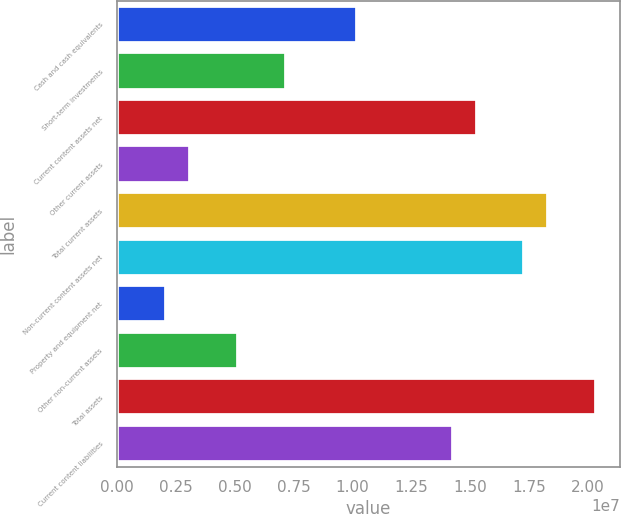Convert chart to OTSL. <chart><loc_0><loc_0><loc_500><loc_500><bar_chart><fcel>Cash and cash equivalents<fcel>Short-term investments<fcel>Current content assets net<fcel>Other current assets<fcel>Total current assets<fcel>Non-current content assets net<fcel>Property and equipment net<fcel>Other non-current assets<fcel>Total assets<fcel>Current content liabilities<nl><fcel>1.02029e+07<fcel>7.15764e+06<fcel>1.52783e+07<fcel>3.09733e+06<fcel>1.83235e+07<fcel>1.73084e+07<fcel>2.08225e+06<fcel>5.12748e+06<fcel>2.03536e+07<fcel>1.42632e+07<nl></chart> 